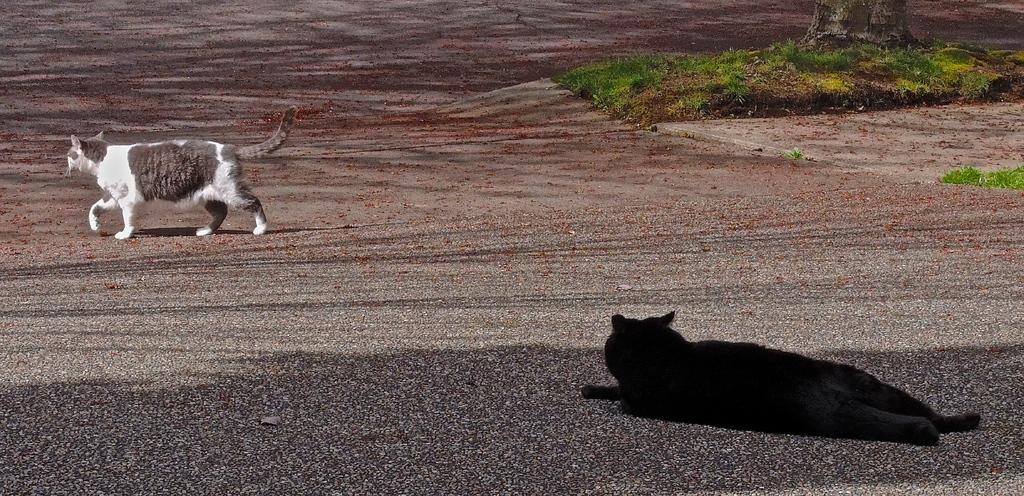Can you describe this image briefly? In this picture we can see a black animal is laying on the path and a cat is walking on the path. Behind the people there is a grass and a tree trunk. 